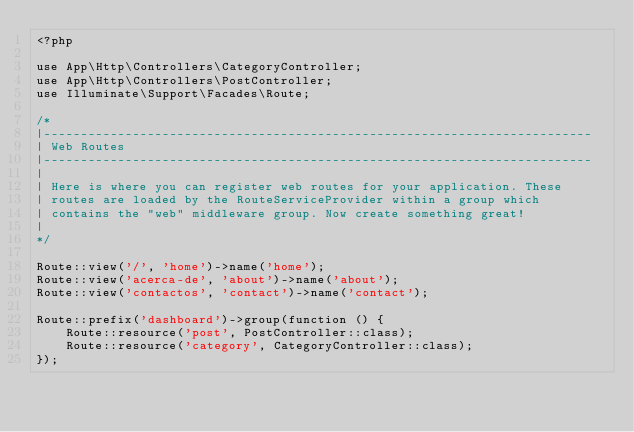Convert code to text. <code><loc_0><loc_0><loc_500><loc_500><_PHP_><?php

use App\Http\Controllers\CategoryController;
use App\Http\Controllers\PostController;
use Illuminate\Support\Facades\Route;

/*
|--------------------------------------------------------------------------
| Web Routes
|--------------------------------------------------------------------------
|
| Here is where you can register web routes for your application. These
| routes are loaded by the RouteServiceProvider within a group which
| contains the "web" middleware group. Now create something great!
|
*/

Route::view('/', 'home')->name('home');
Route::view('acerca-de', 'about')->name('about');
Route::view('contactos', 'contact')->name('contact');

Route::prefix('dashboard')->group(function () {
    Route::resource('post', PostController::class);
    Route::resource('category', CategoryController::class);
});

</code> 